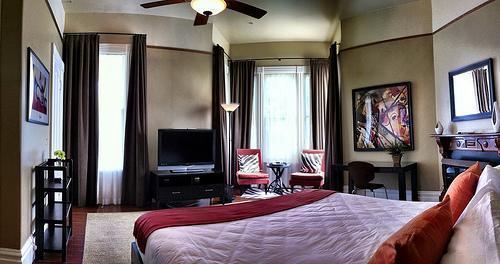How many chairs are at the desk on right side of room?
Give a very brief answer. 1. 